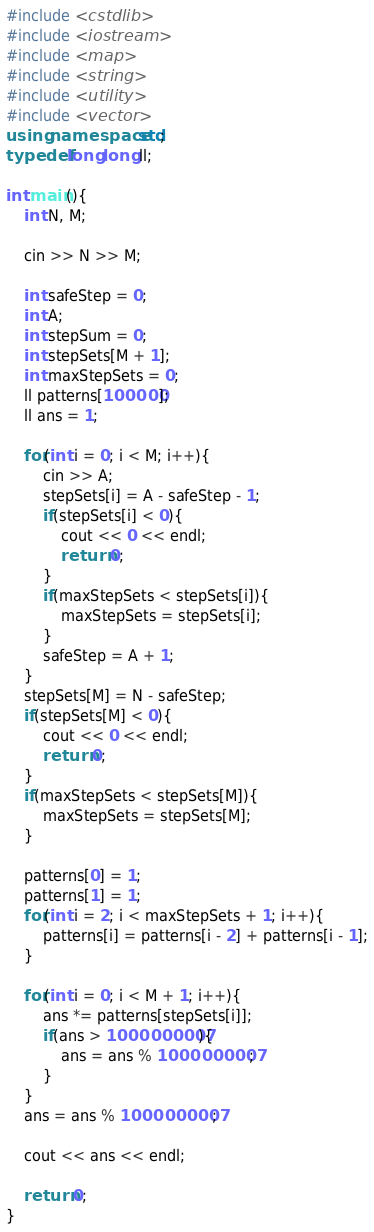<code> <loc_0><loc_0><loc_500><loc_500><_C++_>#include <cstdlib>
#include <iostream>
#include <map>
#include <string>
#include <utility>
#include <vector>
using namespace std;
typedef long long ll;

int main(){
    int N, M;

    cin >> N >> M;

    int safeStep = 0;
    int A;
    int stepSum = 0;
    int stepSets[M + 1];
    int maxStepSets = 0;
    ll patterns[100000];
    ll ans = 1;

    for(int i = 0; i < M; i++){
        cin >> A;
        stepSets[i] = A - safeStep - 1;
        if(stepSets[i] < 0){
            cout << 0 << endl;
            return 0;
        }
        if(maxStepSets < stepSets[i]){
            maxStepSets = stepSets[i];
        }
        safeStep = A + 1;
    }
    stepSets[M] = N - safeStep;
    if(stepSets[M] < 0){
        cout << 0 << endl;
        return 0;
    }
    if(maxStepSets < stepSets[M]){
        maxStepSets = stepSets[M];
    }
    
    patterns[0] = 1;
    patterns[1] = 1;
    for(int i = 2; i < maxStepSets + 1; i++){
        patterns[i] = patterns[i - 2] + patterns[i - 1];
    }

    for(int i = 0; i < M + 1; i++){
        ans *= patterns[stepSets[i]];
        if(ans > 1000000007){
            ans = ans % 1000000007;
        }
    }
    ans = ans % 1000000007;

    cout << ans << endl;

    return 0;
}
</code> 